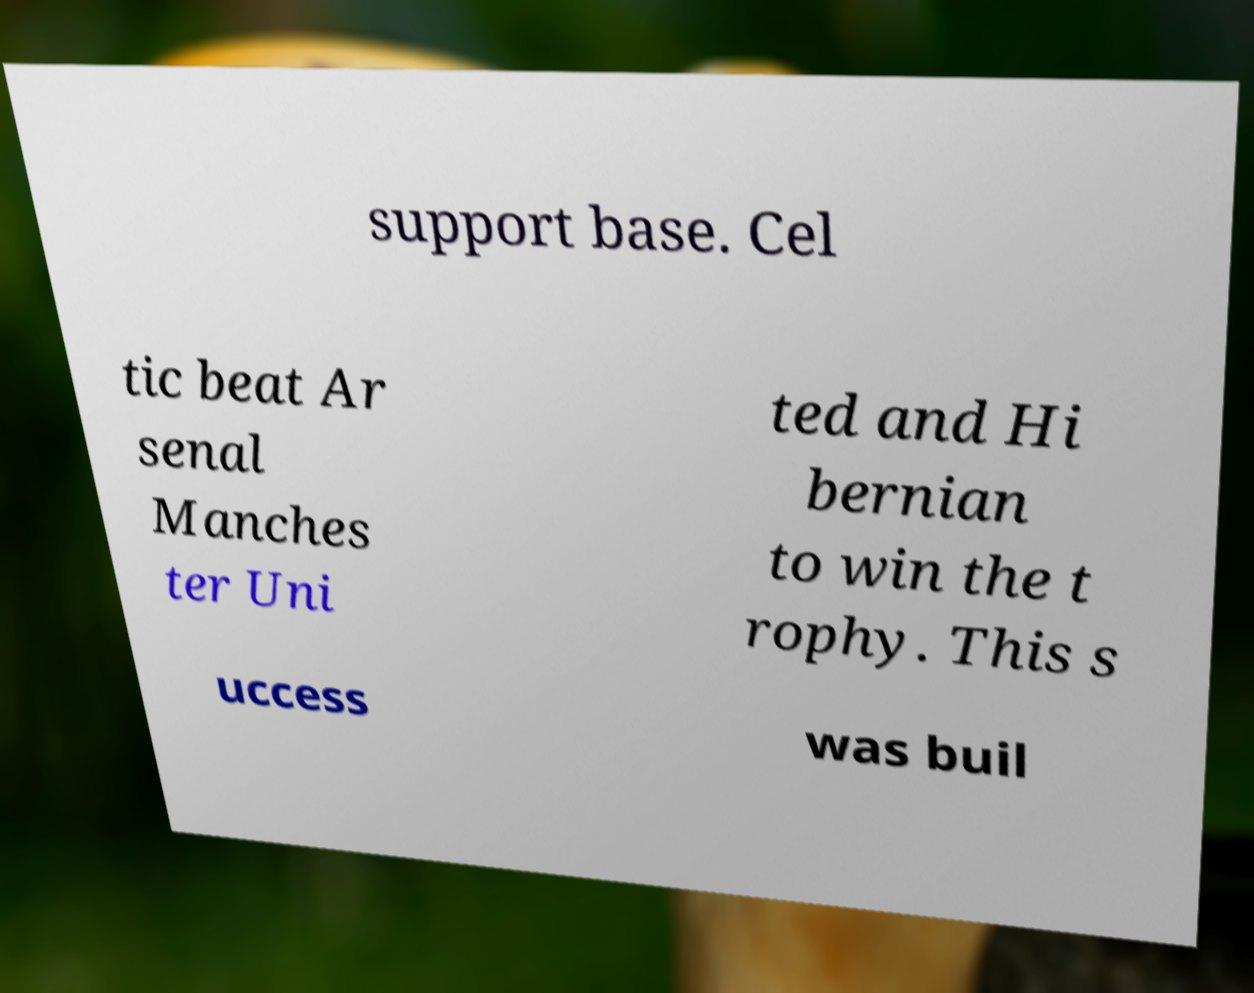Could you assist in decoding the text presented in this image and type it out clearly? support base. Cel tic beat Ar senal Manches ter Uni ted and Hi bernian to win the t rophy. This s uccess was buil 